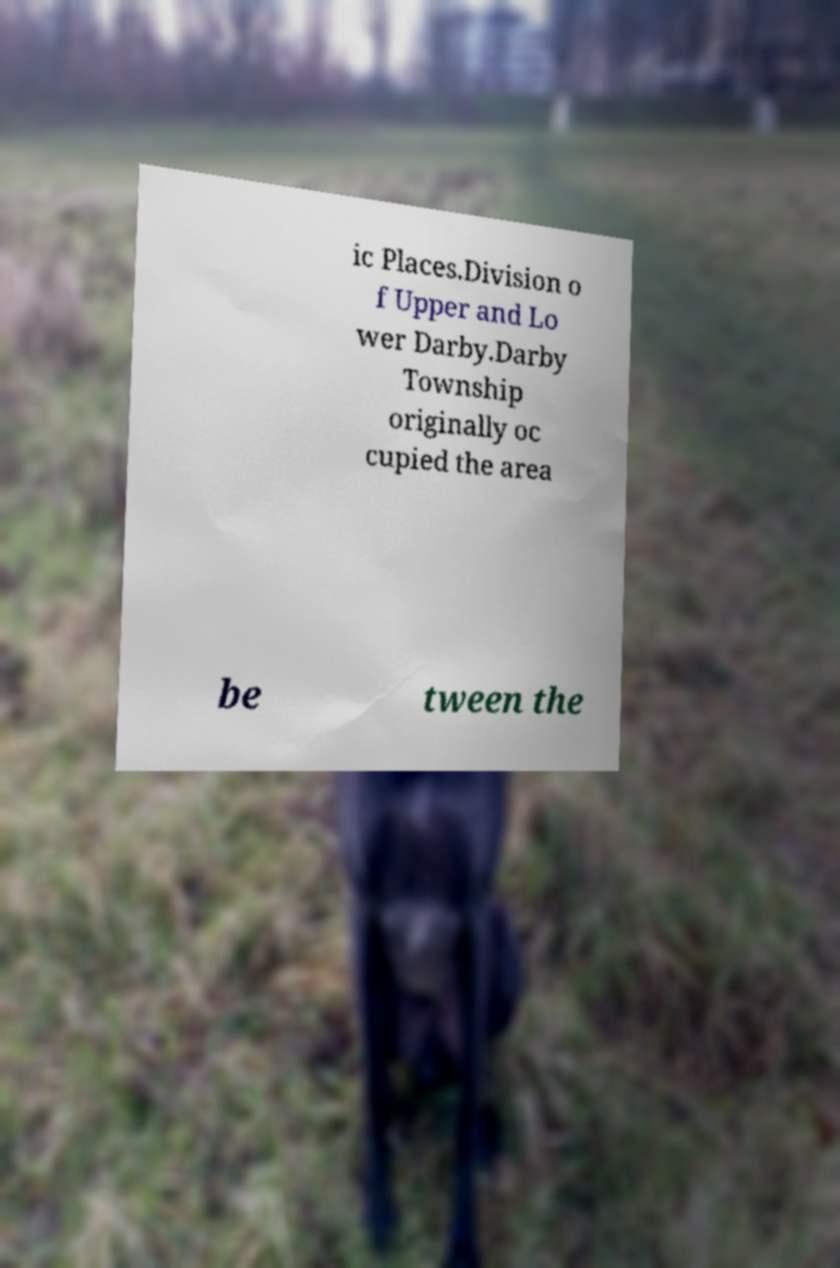There's text embedded in this image that I need extracted. Can you transcribe it verbatim? ic Places.Division o f Upper and Lo wer Darby.Darby Township originally oc cupied the area be tween the 